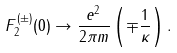<formula> <loc_0><loc_0><loc_500><loc_500>F _ { 2 } ^ { ( \pm ) } ( 0 ) \rightarrow \frac { e ^ { 2 } } { 2 \pi m } \left ( \mp \frac { 1 } { \kappa } \right ) .</formula> 